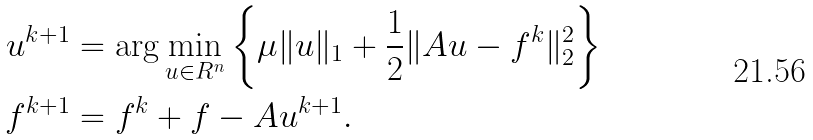<formula> <loc_0><loc_0><loc_500><loc_500>u ^ { k + 1 } & = \arg \min _ { u \in R ^ { n } } \left \{ \mu \| u \| _ { 1 } + \frac { 1 } { 2 } \| A u - f ^ { k } \| _ { 2 } ^ { 2 } \right \} \\ f ^ { k + 1 } & = f ^ { k } + f - A u ^ { k + 1 } .</formula> 